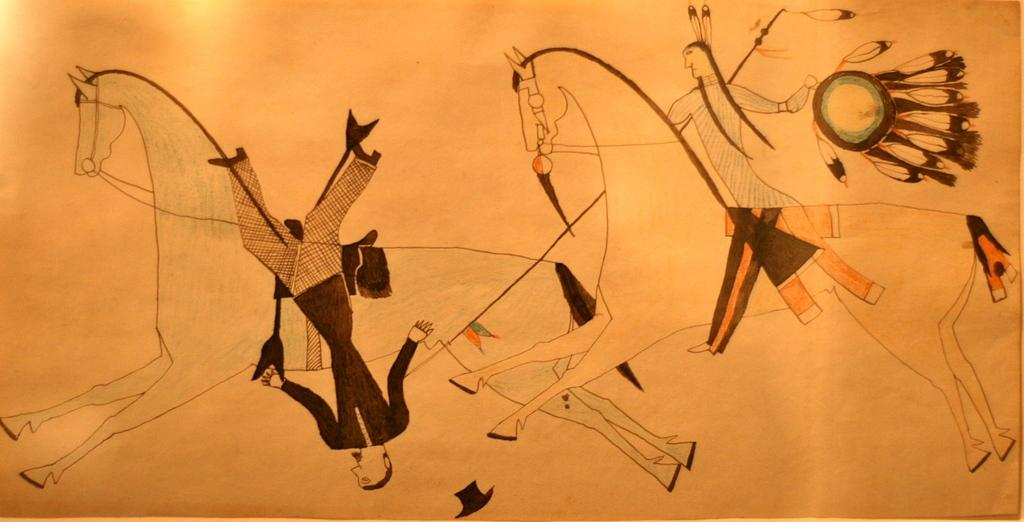What is depicted in the foreground of the image? There is a sketch of a man riding a horse and a sketch of a man falling down from the horse in the foreground of the image. What object can be seen at the bottom of the image? There is a hat at the bottom of the image. Can you tell me how many rabbits are present in the image? There are no rabbits present in the image; it features sketches of a man riding a horse and a man falling down from the horse, along with a hat at the bottom. 